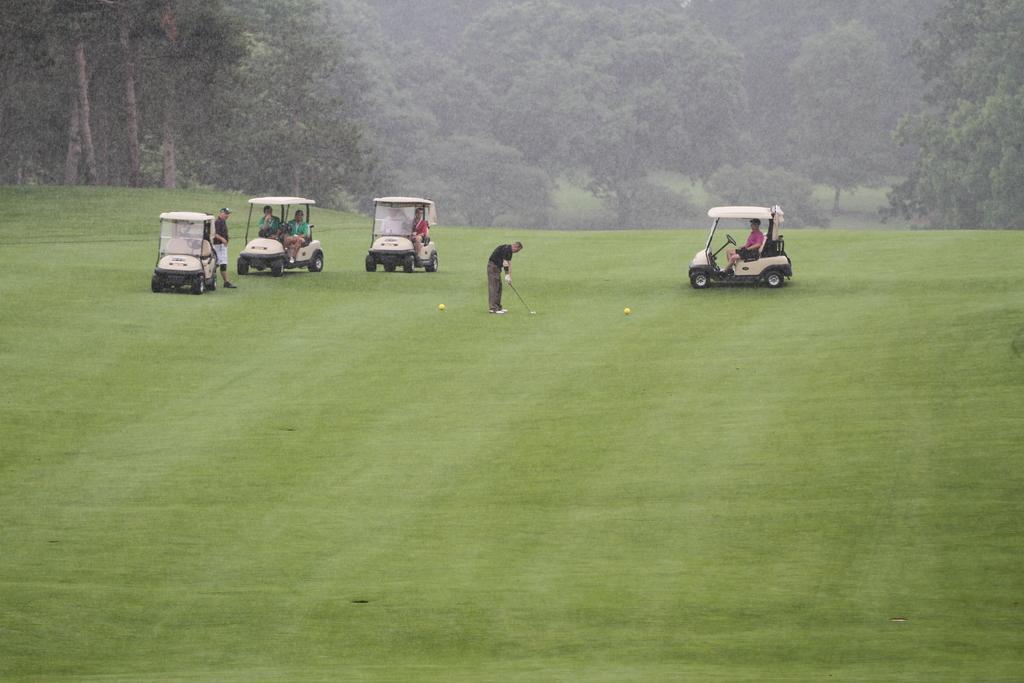Describe this image in one or two sentences. This picture is clicked outside. In the center there is a person standing on the ground and seems to be playing the game and we can see the persons riding vehicles and there is a person standing on the ground and a vehicle parked on the ground. The ground is covered with the green grass. In the background we can see the trees and the plants. 